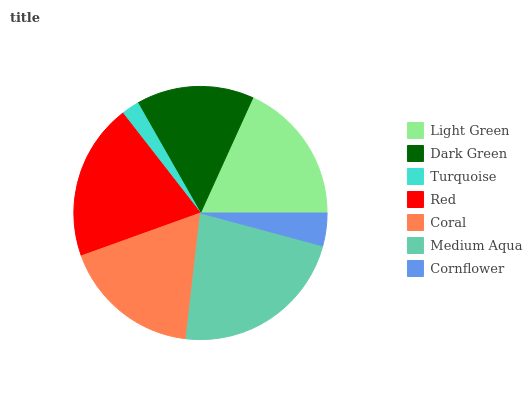Is Turquoise the minimum?
Answer yes or no. Yes. Is Medium Aqua the maximum?
Answer yes or no. Yes. Is Dark Green the minimum?
Answer yes or no. No. Is Dark Green the maximum?
Answer yes or no. No. Is Light Green greater than Dark Green?
Answer yes or no. Yes. Is Dark Green less than Light Green?
Answer yes or no. Yes. Is Dark Green greater than Light Green?
Answer yes or no. No. Is Light Green less than Dark Green?
Answer yes or no. No. Is Coral the high median?
Answer yes or no. Yes. Is Coral the low median?
Answer yes or no. Yes. Is Medium Aqua the high median?
Answer yes or no. No. Is Cornflower the low median?
Answer yes or no. No. 